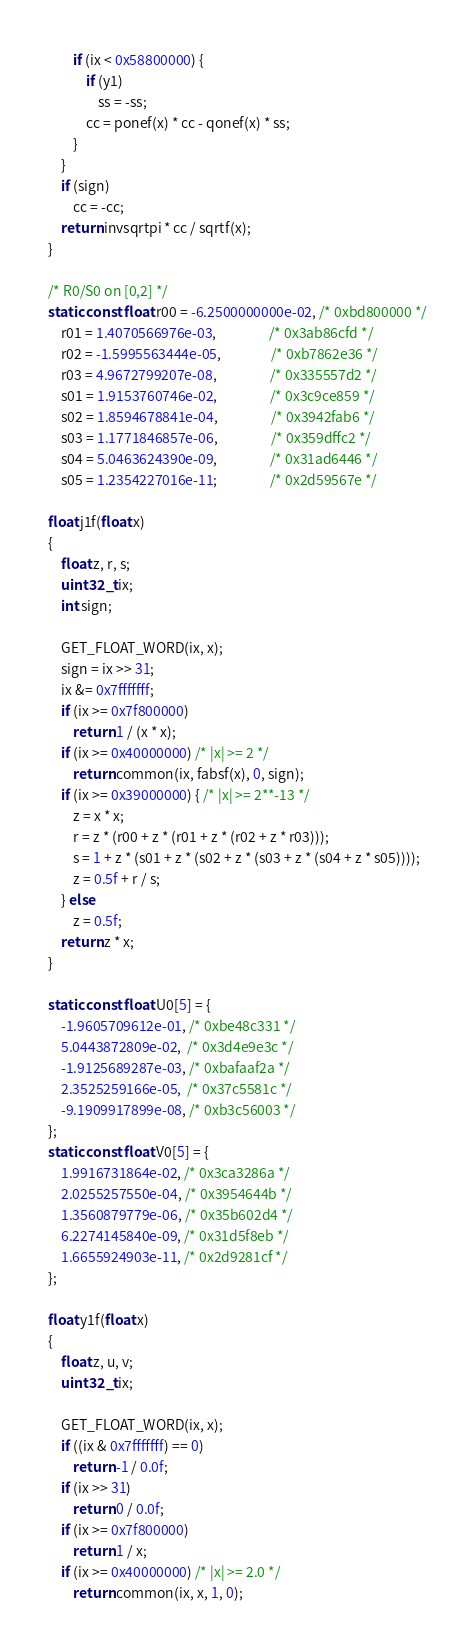<code> <loc_0><loc_0><loc_500><loc_500><_C_>        if (ix < 0x58800000) {
            if (y1)
                ss = -ss;
            cc = ponef(x) * cc - qonef(x) * ss;
        }
    }
    if (sign)
        cc = -cc;
    return invsqrtpi * cc / sqrtf(x);
}

/* R0/S0 on [0,2] */
static const float r00 = -6.2500000000e-02, /* 0xbd800000 */
    r01 = 1.4070566976e-03,                 /* 0x3ab86cfd */
    r02 = -1.5995563444e-05,                /* 0xb7862e36 */
    r03 = 4.9672799207e-08,                 /* 0x335557d2 */
    s01 = 1.9153760746e-02,                 /* 0x3c9ce859 */
    s02 = 1.8594678841e-04,                 /* 0x3942fab6 */
    s03 = 1.1771846857e-06,                 /* 0x359dffc2 */
    s04 = 5.0463624390e-09,                 /* 0x31ad6446 */
    s05 = 1.2354227016e-11;                 /* 0x2d59567e */

float j1f(float x)
{
    float z, r, s;
    uint32_t ix;
    int sign;

    GET_FLOAT_WORD(ix, x);
    sign = ix >> 31;
    ix &= 0x7fffffff;
    if (ix >= 0x7f800000)
        return 1 / (x * x);
    if (ix >= 0x40000000) /* |x| >= 2 */
        return common(ix, fabsf(x), 0, sign);
    if (ix >= 0x39000000) { /* |x| >= 2**-13 */
        z = x * x;
        r = z * (r00 + z * (r01 + z * (r02 + z * r03)));
        s = 1 + z * (s01 + z * (s02 + z * (s03 + z * (s04 + z * s05))));
        z = 0.5f + r / s;
    } else
        z = 0.5f;
    return z * x;
}

static const float U0[5] = {
    -1.9605709612e-01, /* 0xbe48c331 */
    5.0443872809e-02,  /* 0x3d4e9e3c */
    -1.9125689287e-03, /* 0xbafaaf2a */
    2.3525259166e-05,  /* 0x37c5581c */
    -9.1909917899e-08, /* 0xb3c56003 */
};
static const float V0[5] = {
    1.9916731864e-02, /* 0x3ca3286a */
    2.0255257550e-04, /* 0x3954644b */
    1.3560879779e-06, /* 0x35b602d4 */
    6.2274145840e-09, /* 0x31d5f8eb */
    1.6655924903e-11, /* 0x2d9281cf */
};

float y1f(float x)
{
    float z, u, v;
    uint32_t ix;

    GET_FLOAT_WORD(ix, x);
    if ((ix & 0x7fffffff) == 0)
        return -1 / 0.0f;
    if (ix >> 31)
        return 0 / 0.0f;
    if (ix >= 0x7f800000)
        return 1 / x;
    if (ix >= 0x40000000) /* |x| >= 2.0 */
        return common(ix, x, 1, 0);</code> 